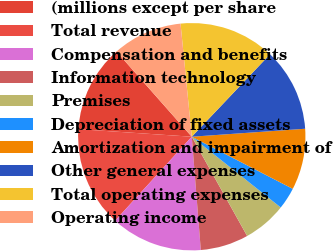Convert chart. <chart><loc_0><loc_0><loc_500><loc_500><pie_chart><fcel>(millions except per share<fcel>Total revenue<fcel>Compensation and benefits<fcel>Information technology<fcel>Premises<fcel>Depreciation of fixed assets<fcel>Amortization and impairment of<fcel>Other general expenses<fcel>Total operating expenses<fcel>Operating income<nl><fcel>12.42%<fcel>14.29%<fcel>13.04%<fcel>6.83%<fcel>6.21%<fcel>3.11%<fcel>8.7%<fcel>11.8%<fcel>13.66%<fcel>9.94%<nl></chart> 